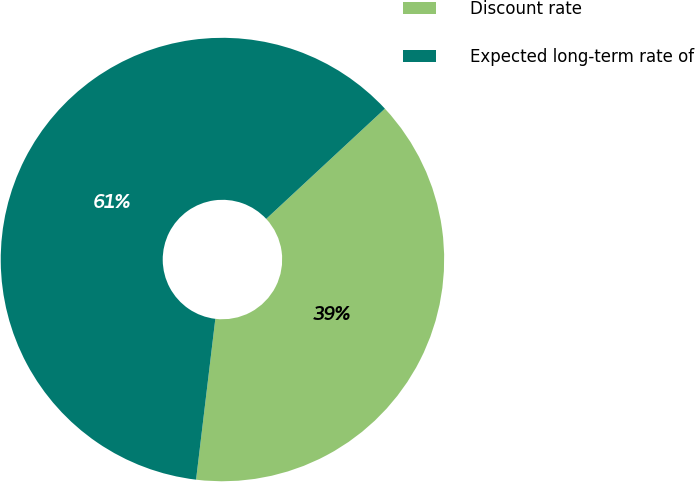<chart> <loc_0><loc_0><loc_500><loc_500><pie_chart><fcel>Discount rate<fcel>Expected long-term rate of<nl><fcel>38.81%<fcel>61.19%<nl></chart> 